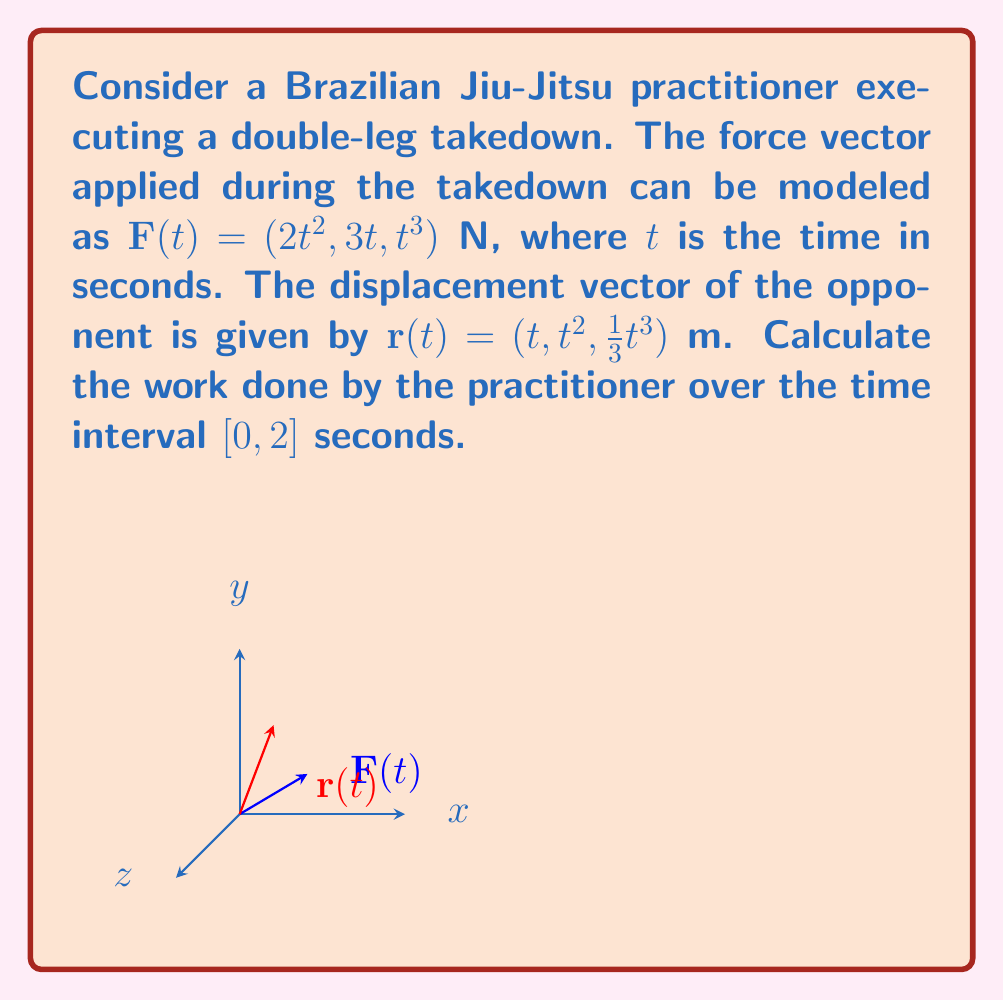Solve this math problem. To calculate the work done, we need to evaluate the line integral of the force vector along the path of displacement. The work is given by:

$$W = \int_C \mathbf{F} \cdot d\mathbf{r}$$

Where $C$ is the path of displacement.

Step 1: Express $d\mathbf{r}$ in terms of $t$.
$$d\mathbf{r} = \frac{d\mathbf{r}}{dt}dt = (1, 2t, t^2)dt$$

Step 2: Calculate the dot product $\mathbf{F} \cdot d\mathbf{r}$.
$$\mathbf{F} \cdot d\mathbf{r} = (2t^2, 3t, t^3) \cdot (1, 2t, t^2)dt$$
$$= (2t^2 + 6t^2 + t^5)dt$$
$$= (8t^2 + t^5)dt$$

Step 3: Integrate from $t=0$ to $t=2$.
$$W = \int_0^2 (8t^2 + t^5)dt$$
$$= \left[\frac{8t^3}{3} + \frac{t^6}{6}\right]_0^2$$
$$= \left(\frac{8(8)}{3} + \frac{64}{6}\right) - \left(0 + 0\right)$$
$$= \frac{64}{3} + \frac{32}{3}$$
$$= 32 \text{ J}$$

Therefore, the work done by the practitioner over the time interval $[0, 2]$ seconds is 32 Joules.
Answer: 32 J 